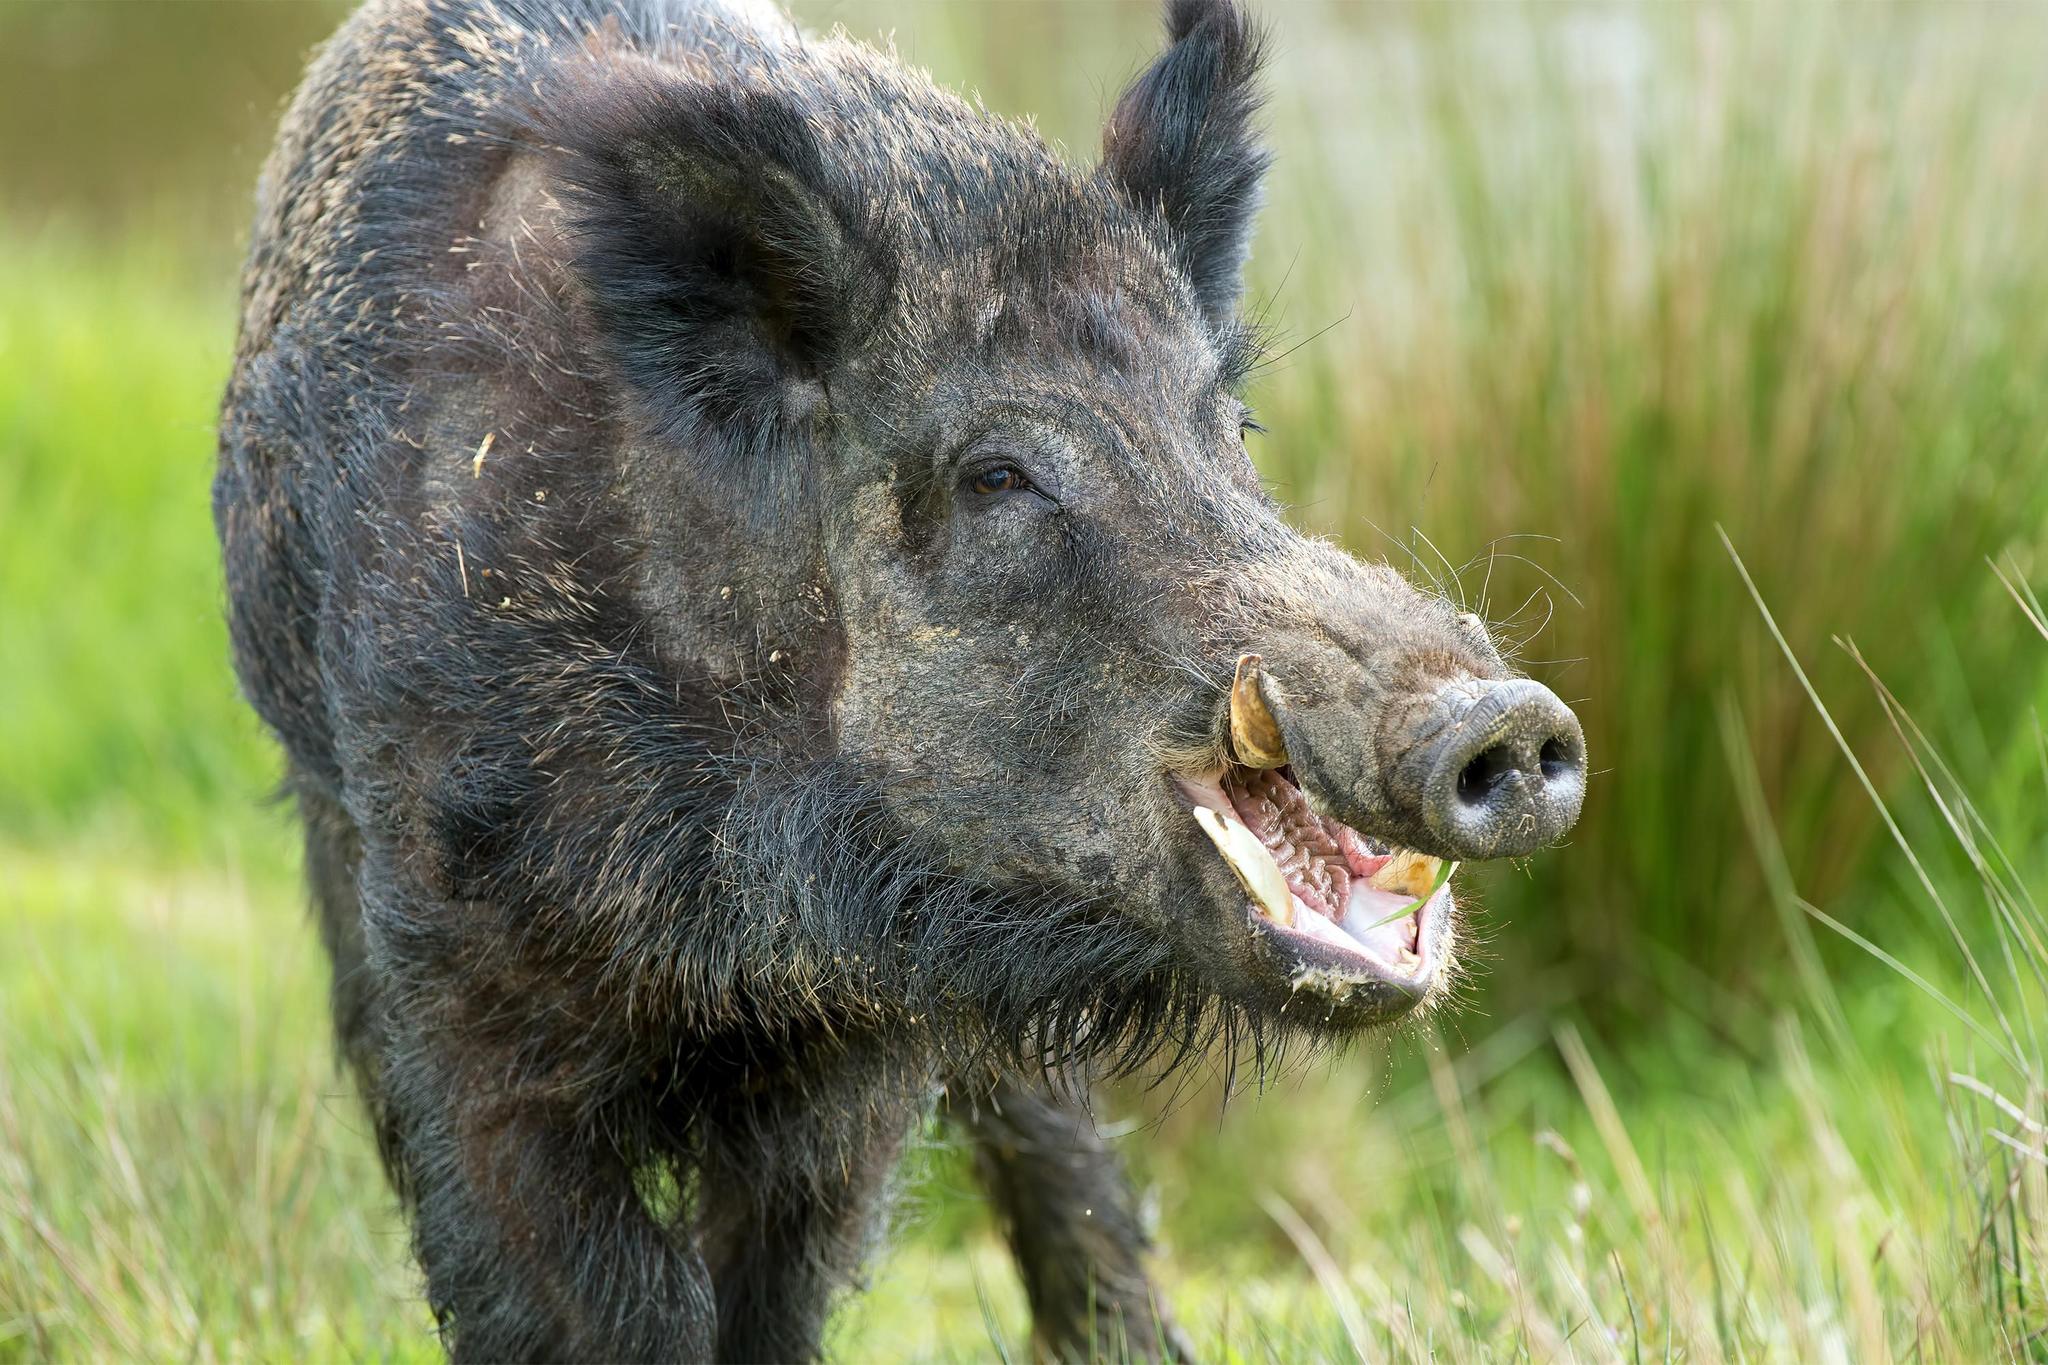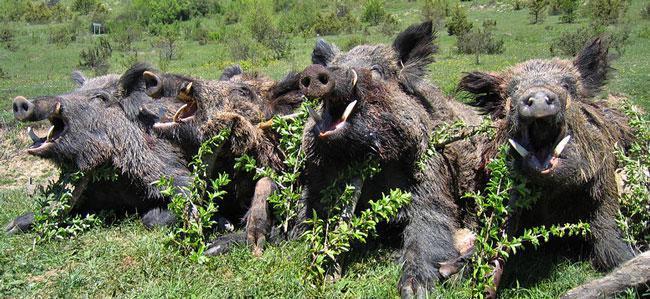The first image is the image on the left, the second image is the image on the right. Assess this claim about the two images: "One wild pig is standing in the grass in the image on the left.". Correct or not? Answer yes or no. Yes. 